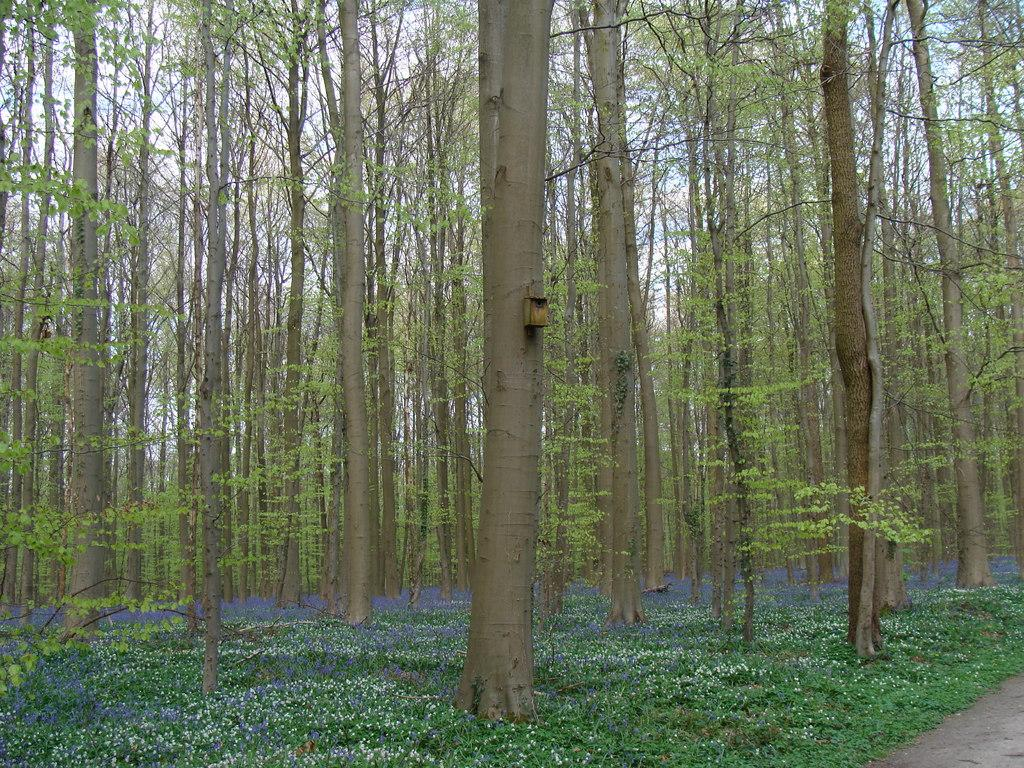What type of vegetation can be seen in the image? There are plants and trees in the image. What part of the natural environment is visible in the image? The sky is visible in the background of the image. What type of print can be seen on the trees in the image? There is no print visible on the trees in the image; they appear to be natural trees without any patterns or designs. 